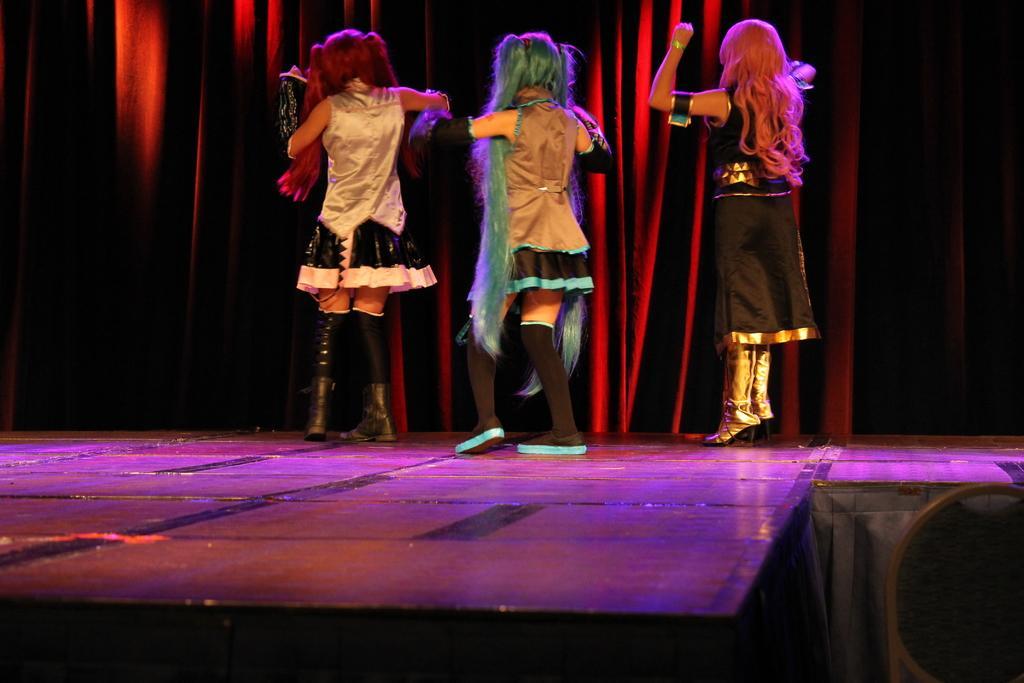In one or two sentences, can you explain what this image depicts? This is an image clicked in the dark. Here I can see three women wearing costume, standing on the stage facing towards the back side. It seems like they are dancing. In the background, I can see a curtain. 